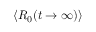Convert formula to latex. <formula><loc_0><loc_0><loc_500><loc_500>\langle R _ { 0 } ( t \rightarrow \infty ) \rangle</formula> 